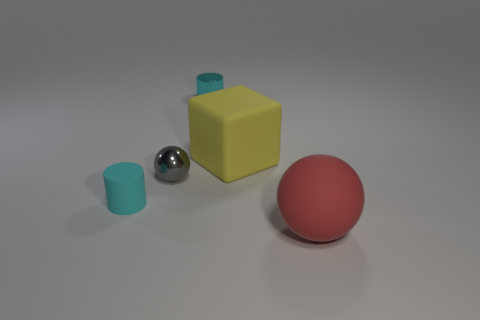Add 2 small cyan metal cylinders. How many objects exist? 7 Subtract all cubes. How many objects are left? 4 Subtract all big blocks. Subtract all gray cylinders. How many objects are left? 4 Add 1 cylinders. How many cylinders are left? 3 Add 4 big red matte balls. How many big red matte balls exist? 5 Subtract 0 gray cylinders. How many objects are left? 5 